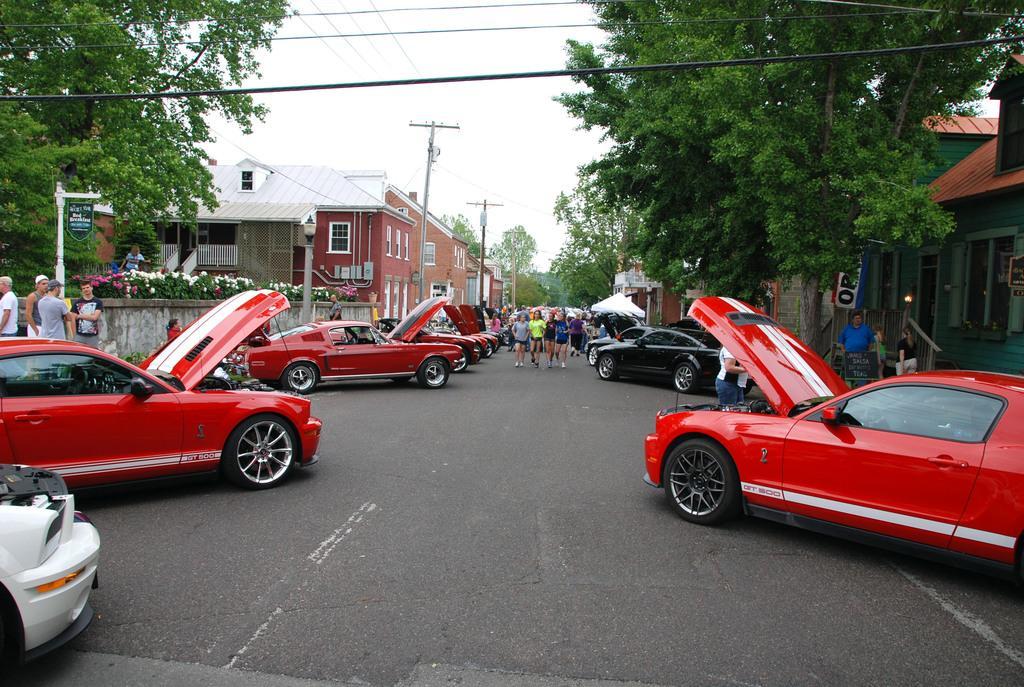Describe this image in one or two sentences. This image consists of many cars. Most of the cars are in red color. At the bottom, there is a road. All the bonnets of the cars are opened. In the background, there are buildings along with trees. And there are many people walking on the road. 